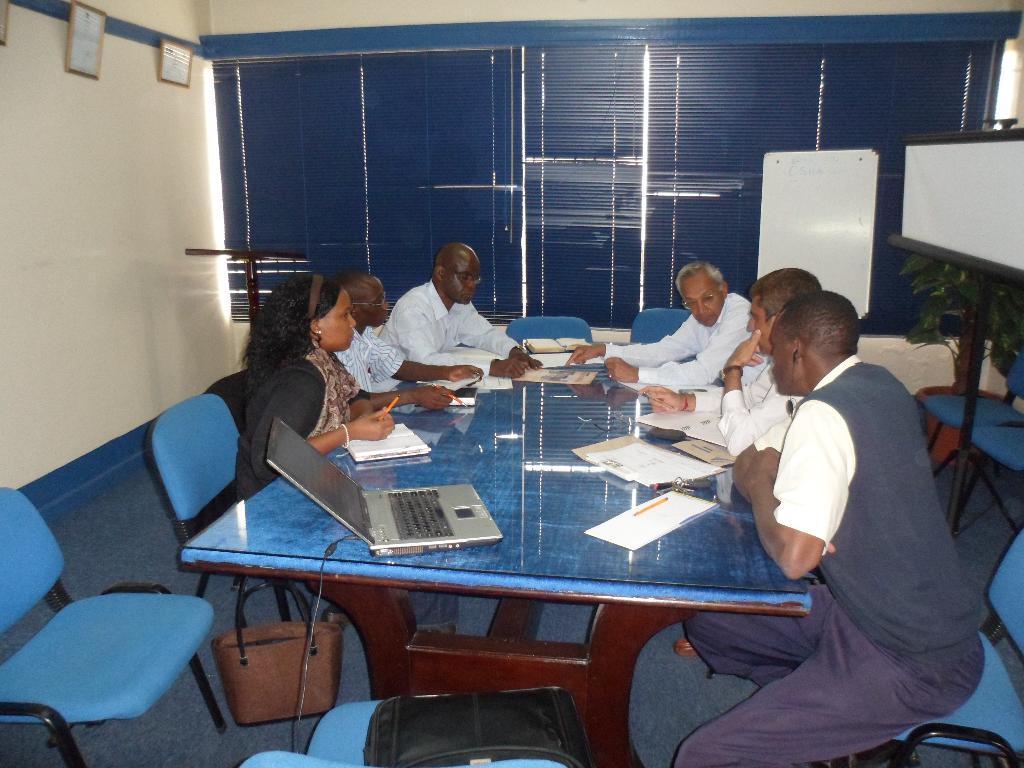Describe this image in one or two sentences. This is the picture inside of the room. There are group of people sitting around the table. There is a laptop, papers, keys, pens, books on the table. at the bottom there is a bag. At the back there is a window. At the left there is a frames on the wall. At the right there is a board. 